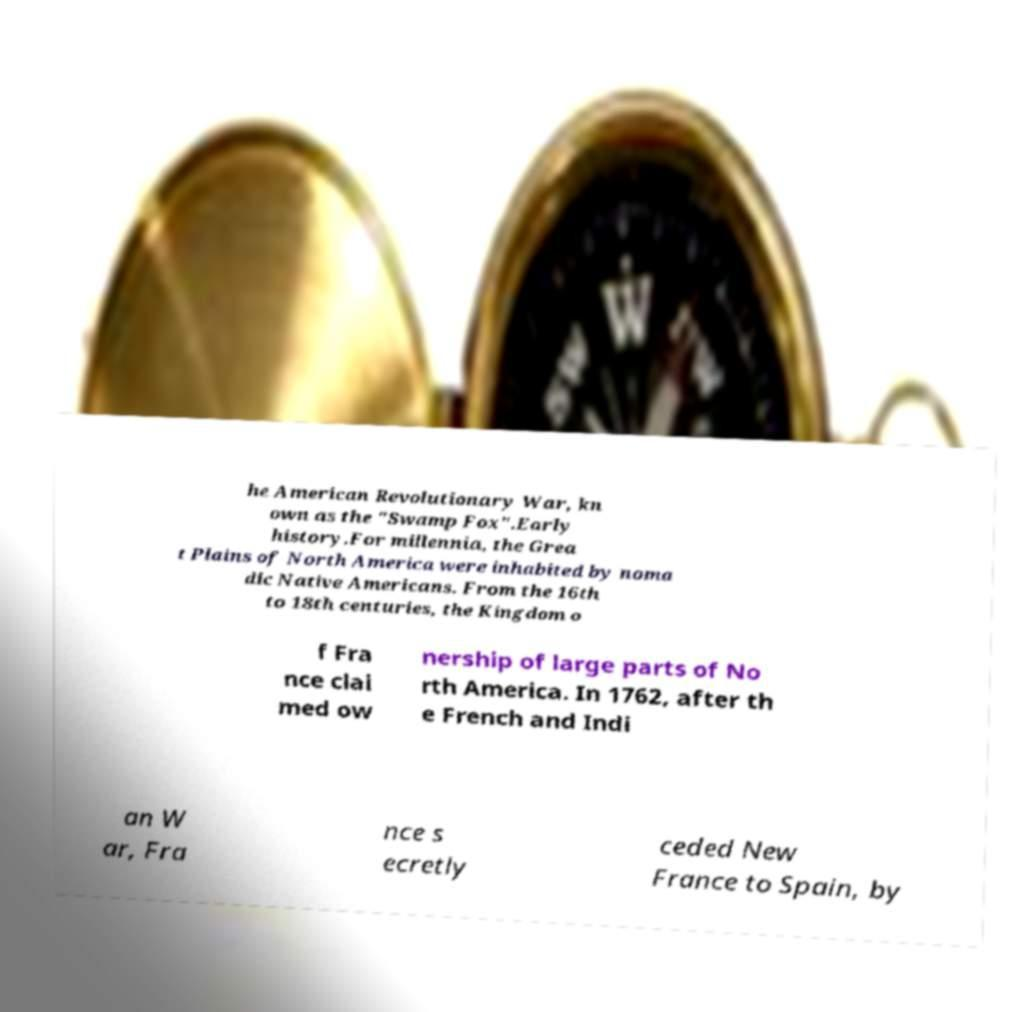Can you accurately transcribe the text from the provided image for me? he American Revolutionary War, kn own as the "Swamp Fox".Early history.For millennia, the Grea t Plains of North America were inhabited by noma dic Native Americans. From the 16th to 18th centuries, the Kingdom o f Fra nce clai med ow nership of large parts of No rth America. In 1762, after th e French and Indi an W ar, Fra nce s ecretly ceded New France to Spain, by 